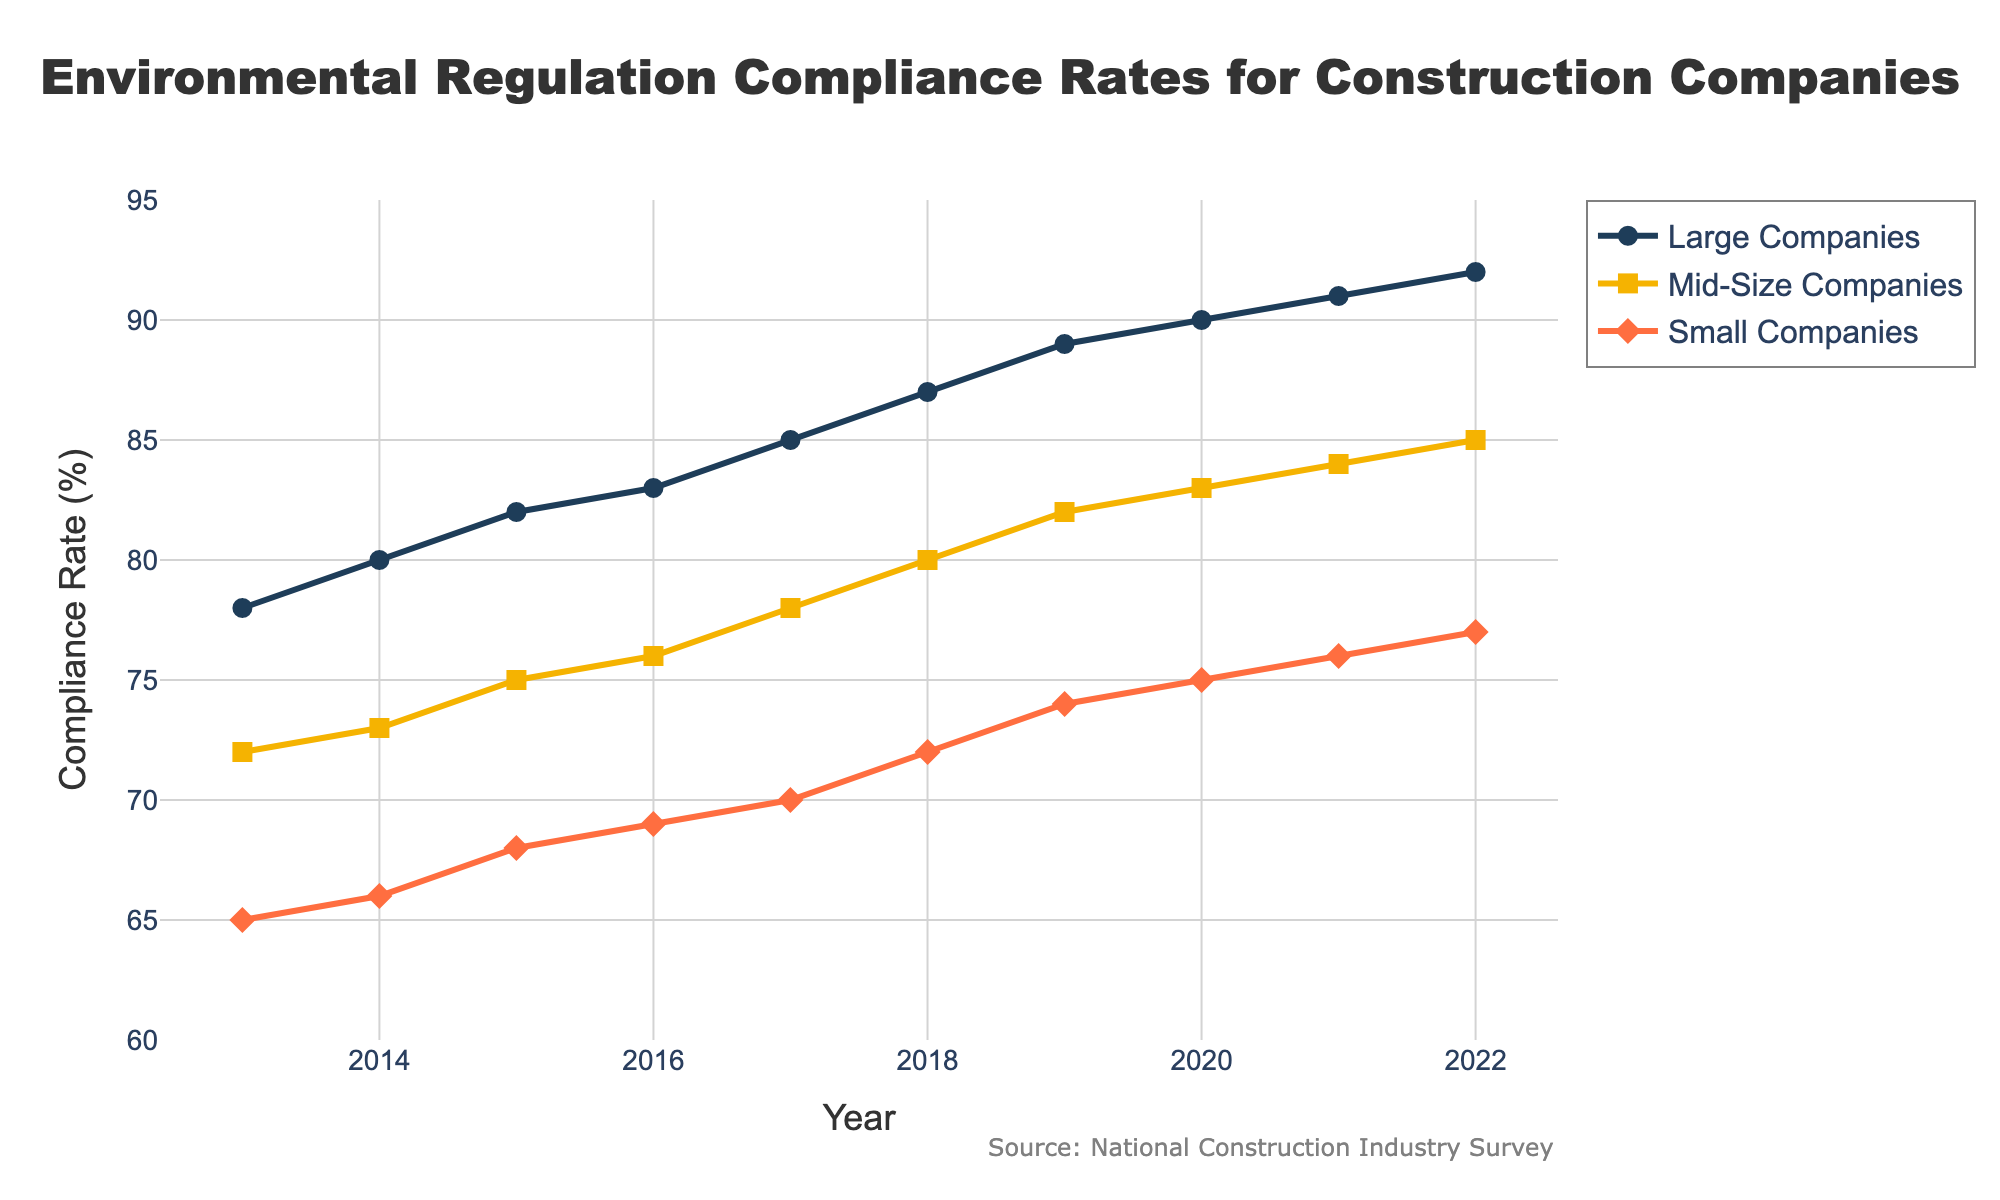How has the compliance rate for large companies changed from 2013 to 2022? To find the change in compliance rate for large companies from 2013 to 2022, look at the compliance rate for large companies in 2013 (78%) and in 2022 (92%). Subtract the 2013 rate from the 2022 rate: 92% - 78% = 14%.
Answer: 14% Which year did mid-size companies see the largest annual increase in compliance rate? To determine the year with the largest annual increase for mid-size companies, compare the year-over-year changes. The differences are: 2014-2013 (1%), 2015-2014 (2%), 2016-2015 (1%), 2017-2016 (2%), 2018-2017 (2%), 2019-2018 (2%), 2020-2019 (1%), 2021-2020 (1%), 2022-2021 (1%). The largest increase is in 2015, 2017, 2018, and 2019, all with 2%.
Answer: 2015, 2017, 2018, 2019 How do the compliance rates of small companies in 2020 compare to those of mid-size companies in 2018? Look at the compliance rate for small companies in 2020 (75%) and for mid-size companies in 2018 (80%). Compare the two rates: 75% < 80%.
Answer: 75% < 80% What is the overall trend in compliance rates for small companies from 2013 to 2022? Observe the compliance rates for small companies over the years. The rates start at 65% in 2013 and increase each year up to 77% in 2022, showing a consistent upward trend.
Answer: Upward trend Among the three company sizes, which one showed the highest compliance rate in 2016? Check the compliance rates for each company size in 2016: Large (83%), Mid-Size (76%), and Small (69%). The highest rate is for large companies.
Answer: Large companies What's the difference in compliance rates between large and small companies in 2019? Observe the compliance rate for large companies in 2019 (89%) and for small companies in 2019 (74%). Subtract the latter from the former: 89% - 74% = 15%.
Answer: 15% Considering the compliance rate changes, which company size showed the most significant improvement from 2013 to 2022? Compare the changes in compliance rates from 2013 to 2022 for each company size. For Large companies: 92% - 78% = 14%, Mid-Size companies: 85% - 72% = 13%, Small companies: 77% - 65% = 12%. The most significant improvement is for large companies.
Answer: Large companies Did any company size’s compliance rate reach a plateau during the observed period? Look for a period where compliance rates did not change or changed minimally across years. None of the company sizes shows a plateau; each size demonstrates a consistent increase in compliance rates.
Answer: No Which company size had the lowest compliance rate in 2021 and what was it? In 2021, check the compliance rates for Large (91%), Mid-Size (84%), and Small (76%) companies. The lowest rate among these is for small companies with a compliance rate of 76%.
Answer: Small companies, 76% 